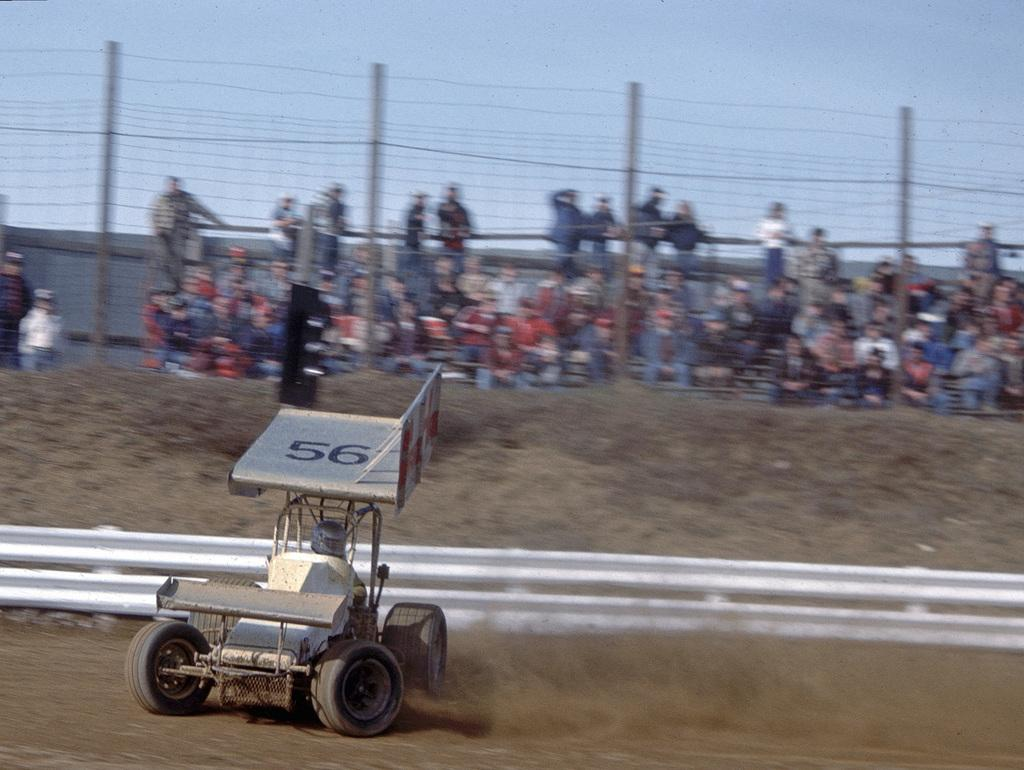What type of vehicle is on the left side of the image? There is a racing car on the left side of the image. What can be seen in the background of the image? There is fencing and people sitting in the background of the image. What is the color of the sky in the image? The sky is blue in the image. Where is the carpenter working in the image? There is no carpenter present in the image. What type of food is being served in the lunchroom in the image? There is no lunchroom present in the image. 